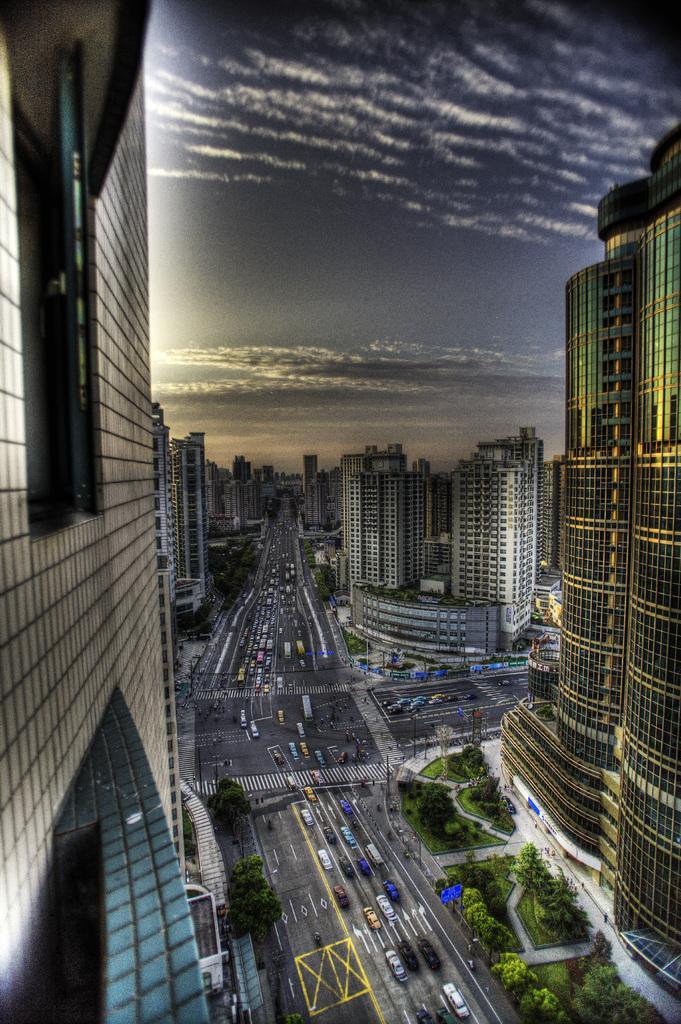Can you describe this image briefly? This image consists of buildings. There are cars in the middle. There is sky at the top. There are trees at the bottom. 